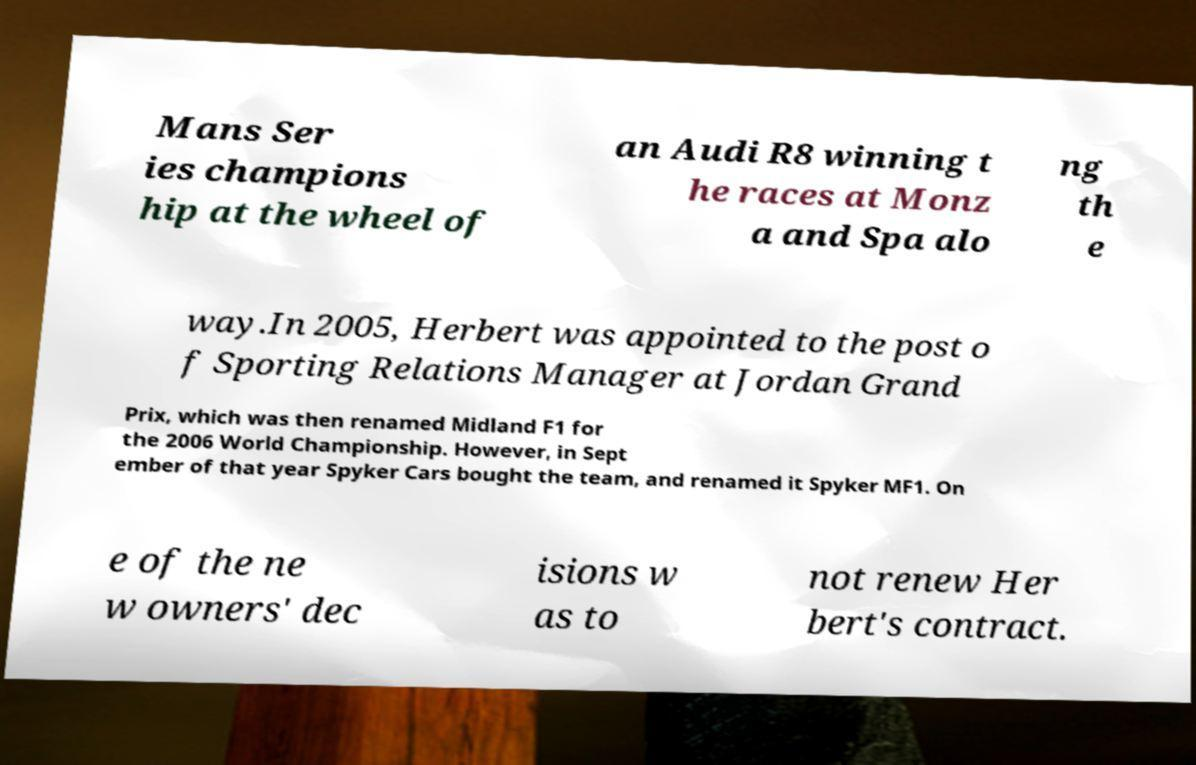What messages or text are displayed in this image? I need them in a readable, typed format. Mans Ser ies champions hip at the wheel of an Audi R8 winning t he races at Monz a and Spa alo ng th e way.In 2005, Herbert was appointed to the post o f Sporting Relations Manager at Jordan Grand Prix, which was then renamed Midland F1 for the 2006 World Championship. However, in Sept ember of that year Spyker Cars bought the team, and renamed it Spyker MF1. On e of the ne w owners' dec isions w as to not renew Her bert's contract. 